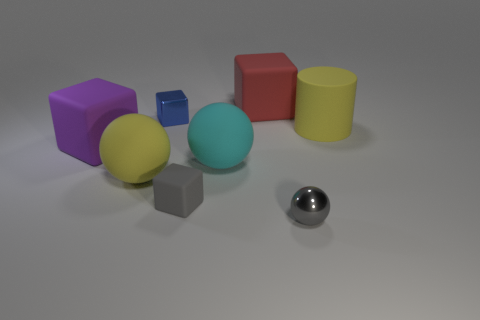Add 2 big purple metallic balls. How many objects exist? 10 Subtract all cyan blocks. Subtract all red cylinders. How many blocks are left? 4 Subtract all cylinders. How many objects are left? 7 Subtract all large matte cubes. Subtract all red cubes. How many objects are left? 5 Add 2 large spheres. How many large spheres are left? 4 Add 3 gray metallic balls. How many gray metallic balls exist? 4 Subtract 0 purple cylinders. How many objects are left? 8 